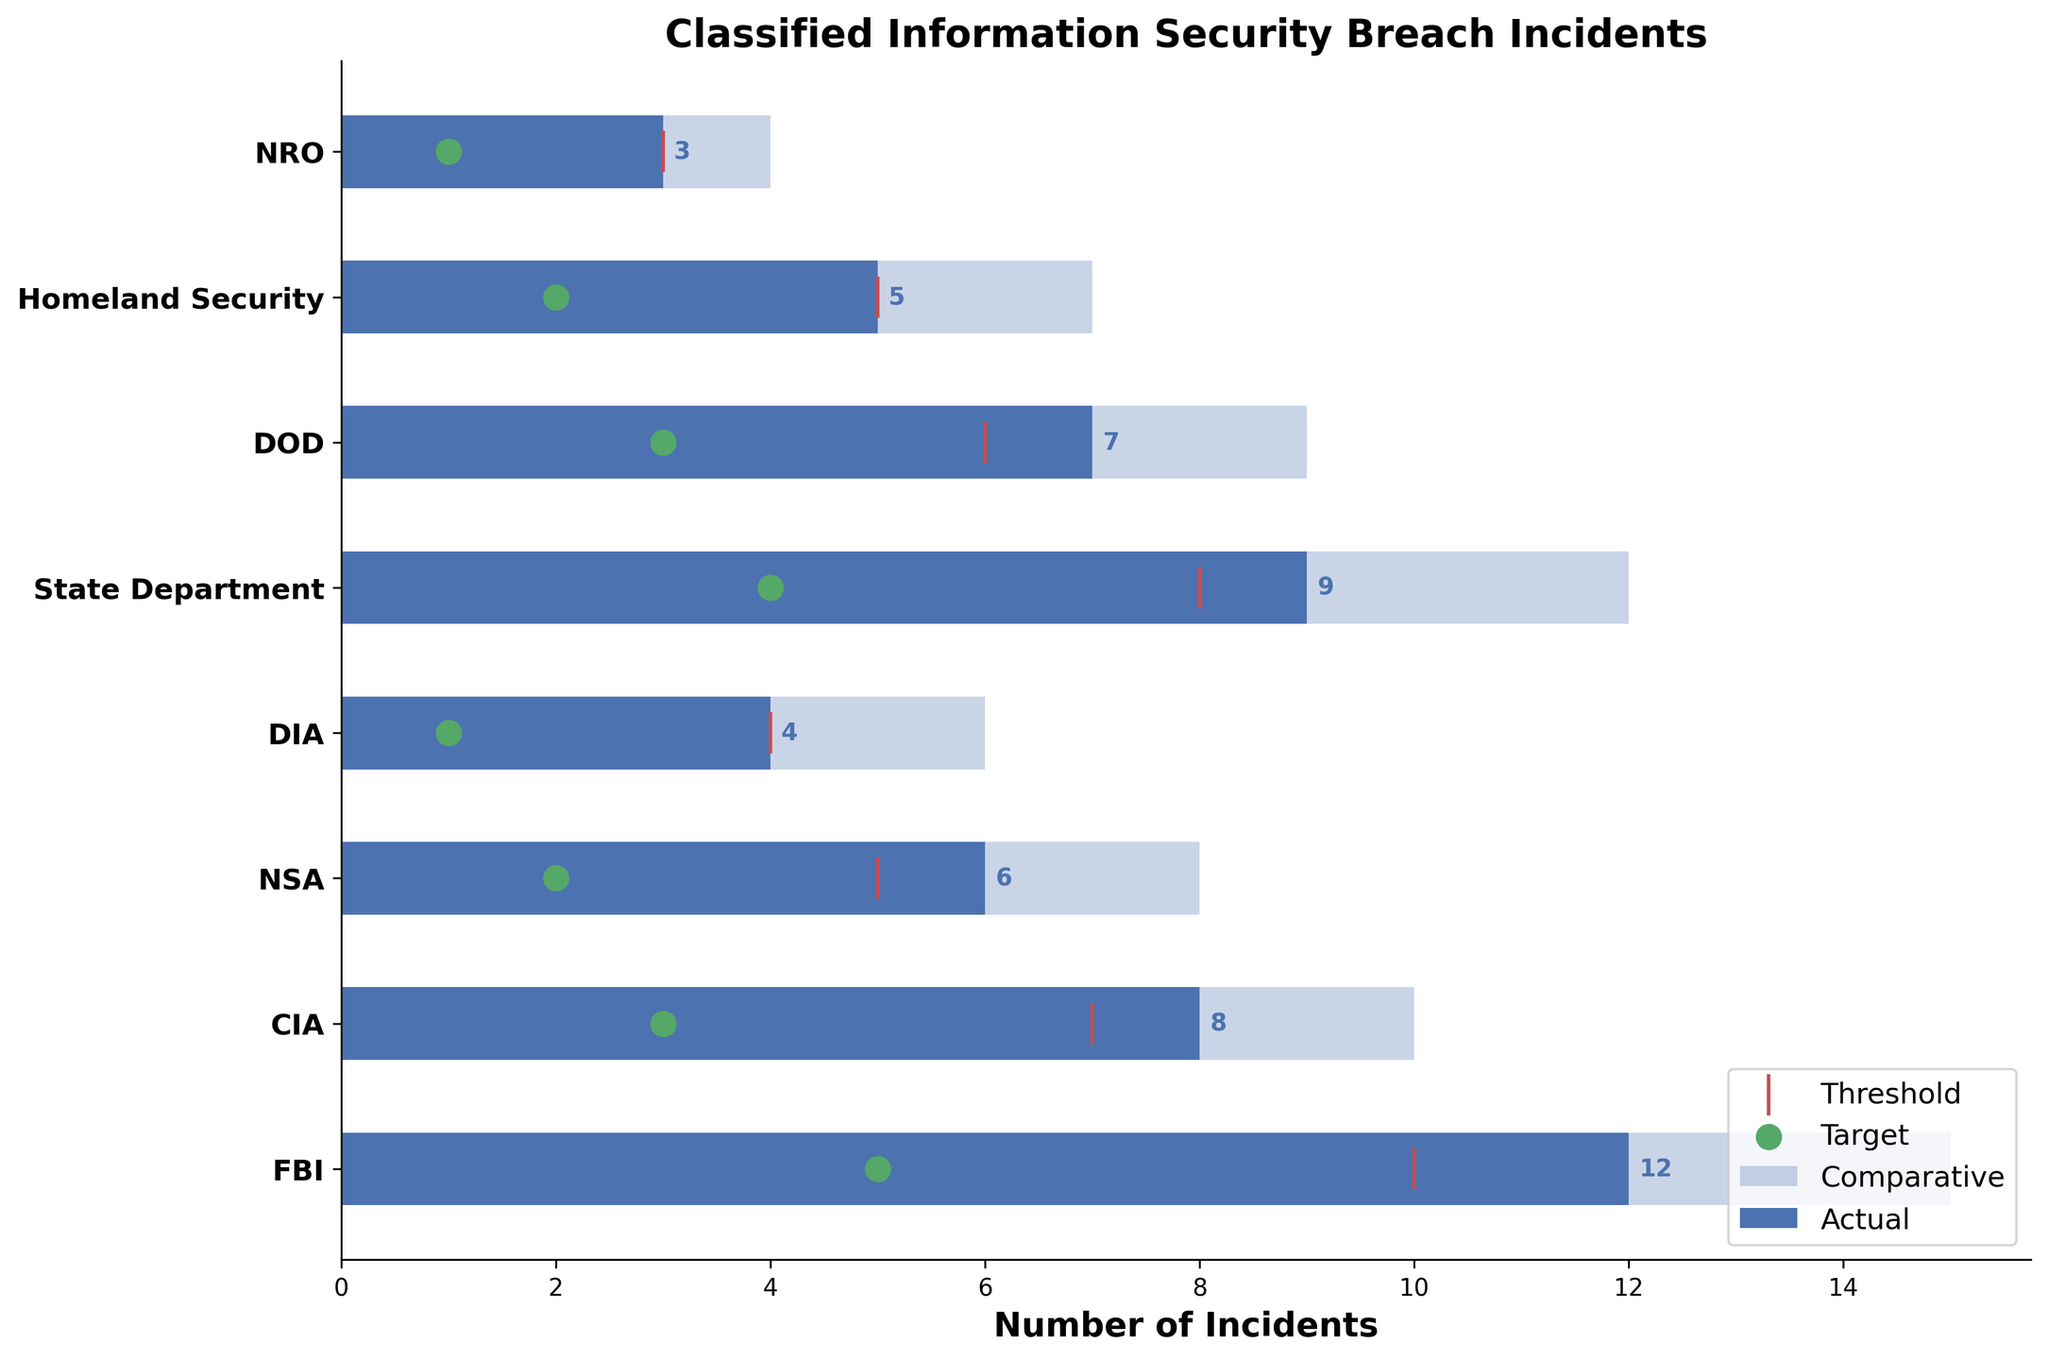What is the title of the plot? The title is given directly at the top of the plot.
Answer: Classified Information Security Breach Incidents How many categories are there in the plot? Count the number of y-axis labels.
Answer: Eight Which category has the highest number of actual incidents? Compare the actual values for all categories. FBI has the highest actual number with 12 incidents.
Answer: FBI What is the actual value for the State Department? Locate the State Department on the y-axis and check the corresponding bar value.
Answer: 9 Which categories meet their target values? Compare actual values to their respective targets and identify the categories where actual >= target. All categories meet or exceed their targets except for the State Department.
Answer: FBI, CIA, NSA, DIA, DOD, Homeland Security, NRO What is the difference in incidents between the FBI and CIA in the actual category? Subtract the number of actual incidents of the CIA from those of the FBI.
Answer: 4 What’s the total number of actual incidents for all categories? Sum the actual values for all categories: 12+8+6+4+9+7+5+3=54.
Answer: 54 Which category's comparative value is closest to its threshold? Subtract the threshold from the comparative values for each category and find the smallest difference. For DIA, the comparative is 6 and the threshold is 4, so the difference is 2, which is the smallest difference.
Answer: DIA How many categories have an actual value greater than their comparative value? Compare the actual and comparative values for each category to see how many actual values are greater: FBI (12<15), CIA (8<10), NSA (6<8), DIA (4<6), State Department (9<12), DOD (7<9), Homeland Security (5<7), NRO (3<4). None of the actual values are greater than their comparative values.
Answer: None What proportion of categories have a threshold lower than their target? Check each category to see if the threshold value is lower than the target value and count those that meet this condition: FBI (10>5), CIA (7>3), NSA (5>2), DIA (4>1), State Department (8>4), DOD (6>3), Homeland Security (5>2), NRO (3>1). All categories meet this condition, so the proportion is 8/8.
Answer: 1 or 100% What is the difference between the highest target and the lowest target value among all categories? Identify the highest and lowest target values (5 and 1, respectively) and subtract the lowest from the highest: 5-1.
Answer: 4 